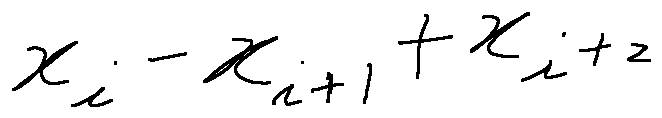Convert formula to latex. <formula><loc_0><loc_0><loc_500><loc_500>x _ { i } - x _ { i + 1 } + x _ { i + 2 }</formula> 